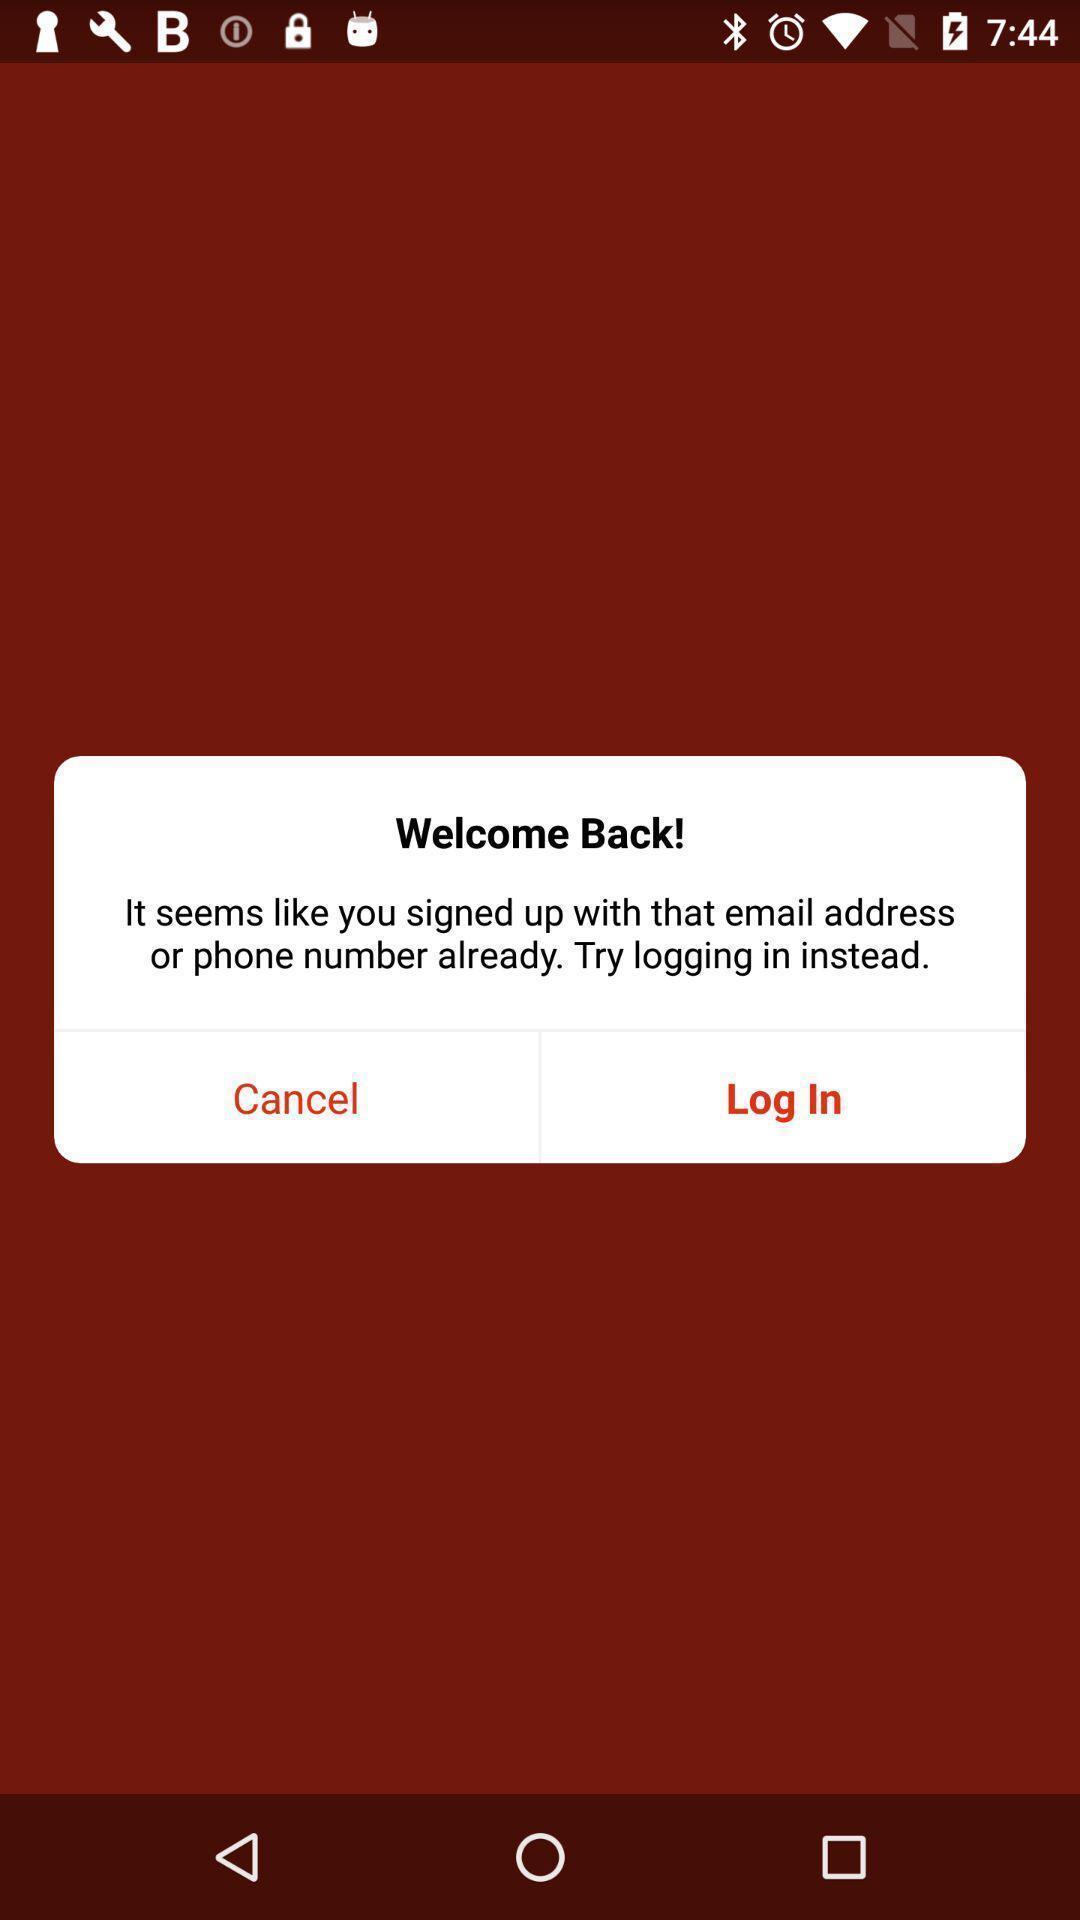Describe the visual elements of this screenshot. Welcome page. 